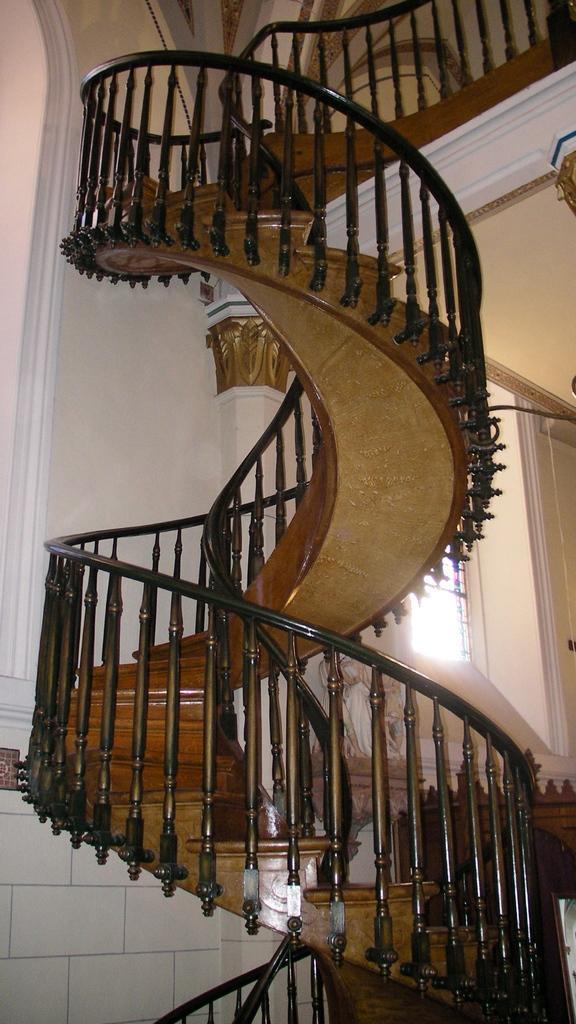In one or two sentences, can you explain what this image depicts? In this image I can see stairs in black color. Background I can see wall in white color and I can also see a window. 